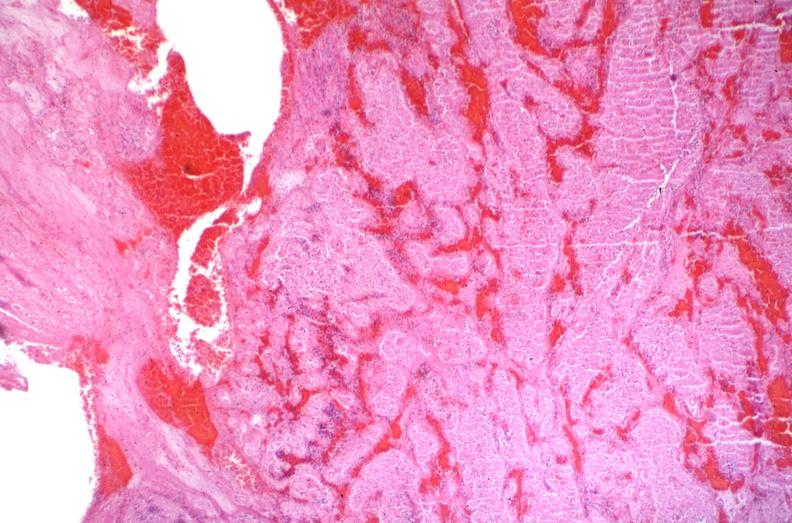s muscle atrophy present?
Answer the question using a single word or phrase. No 